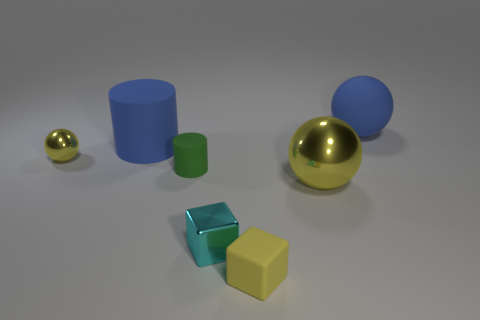Subtract all small yellow balls. How many balls are left? 2 Add 1 big blue cylinders. How many objects exist? 8 Subtract all green cylinders. How many cylinders are left? 1 Add 1 small cyan metallic things. How many small cyan metallic things are left? 2 Add 5 yellow rubber things. How many yellow rubber things exist? 6 Subtract 0 red cylinders. How many objects are left? 7 Subtract all cylinders. How many objects are left? 5 Subtract 2 blocks. How many blocks are left? 0 Subtract all blue cylinders. Subtract all blue blocks. How many cylinders are left? 1 Subtract all gray cylinders. How many brown spheres are left? 0 